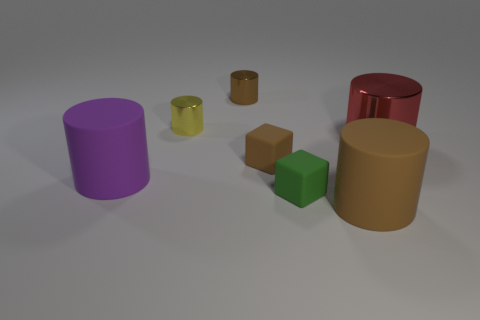How big is the brown shiny thing?
Ensure brevity in your answer.  Small. There is a large purple thing; what shape is it?
Your answer should be compact. Cylinder. Are there any other things that have the same shape as the brown shiny thing?
Provide a short and direct response. Yes. Is the number of tiny brown matte objects behind the red metallic cylinder less than the number of big brown matte objects?
Ensure brevity in your answer.  Yes. Do the large thing that is to the left of the small brown cylinder and the large shiny cylinder have the same color?
Offer a terse response. No. How many shiny objects are either small cylinders or big purple things?
Provide a succinct answer. 2. There is another cylinder that is the same material as the purple cylinder; what is its color?
Your response must be concise. Brown. How many cylinders are large red metallic objects or large objects?
Your answer should be compact. 3. How many objects are large blue matte balls or brown objects behind the tiny green rubber cube?
Provide a short and direct response. 2. Is there a yellow rubber object?
Your answer should be very brief. No. 